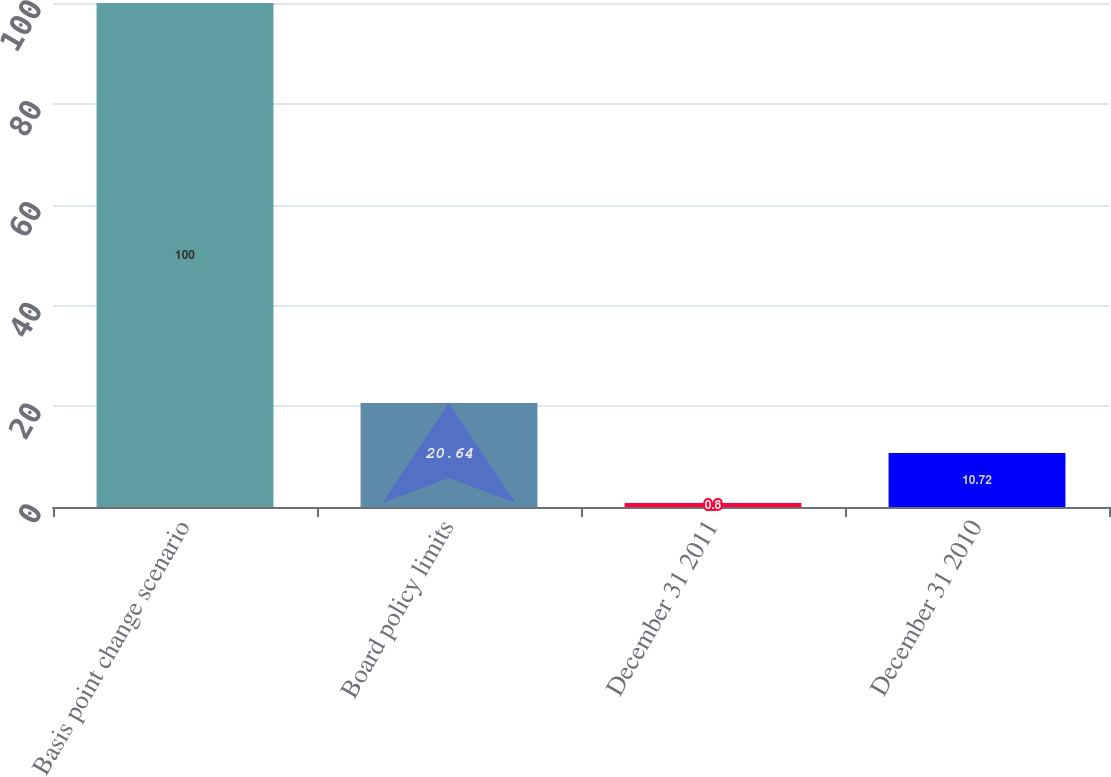Convert chart. <chart><loc_0><loc_0><loc_500><loc_500><bar_chart><fcel>Basis point change scenario<fcel>Board policy limits<fcel>December 31 2011<fcel>December 31 2010<nl><fcel>100<fcel>20.64<fcel>0.8<fcel>10.72<nl></chart> 